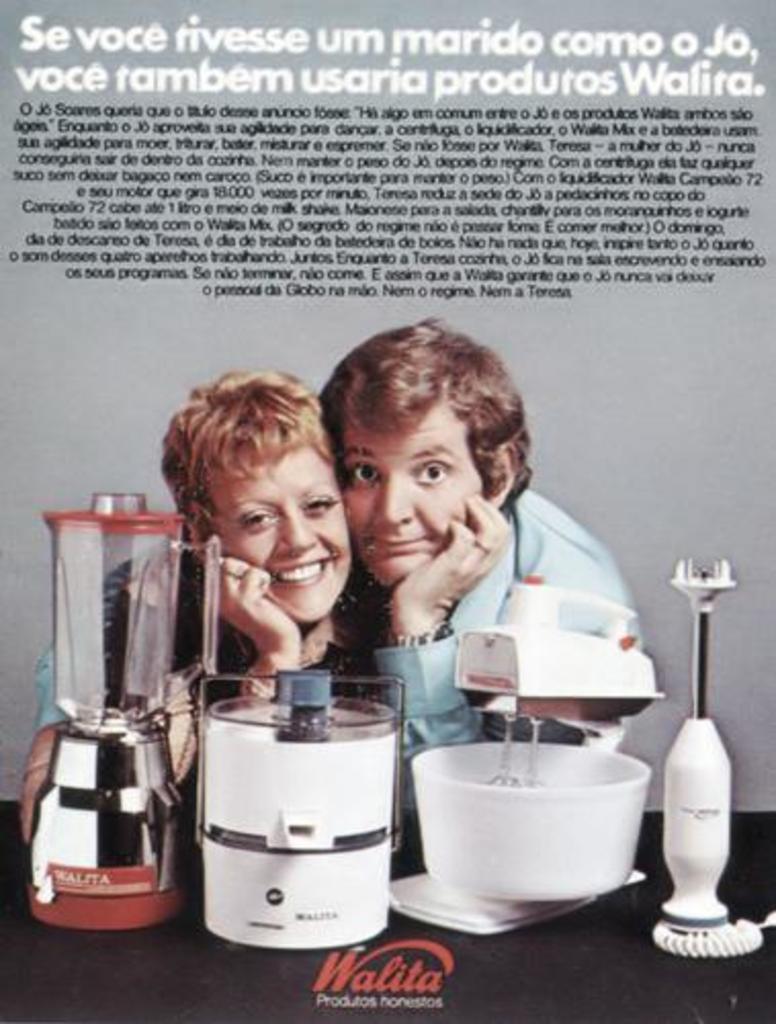What is the name of the company being advertised?
Your response must be concise. Walita. 